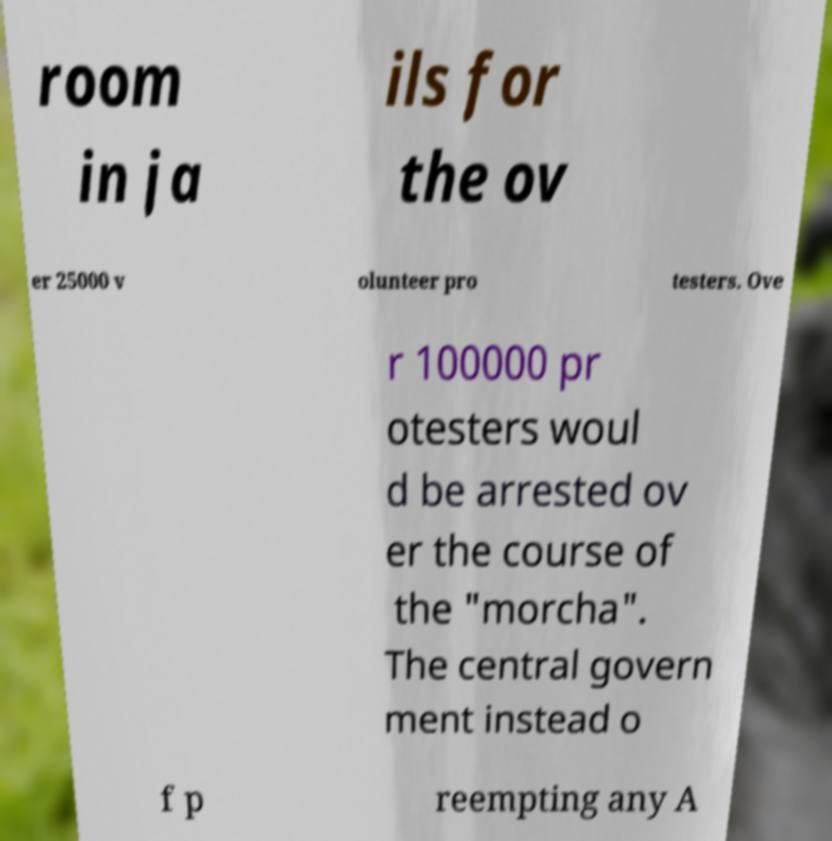What messages or text are displayed in this image? I need them in a readable, typed format. room in ja ils for the ov er 25000 v olunteer pro testers. Ove r 100000 pr otesters woul d be arrested ov er the course of the "morcha". The central govern ment instead o f p reempting any A 